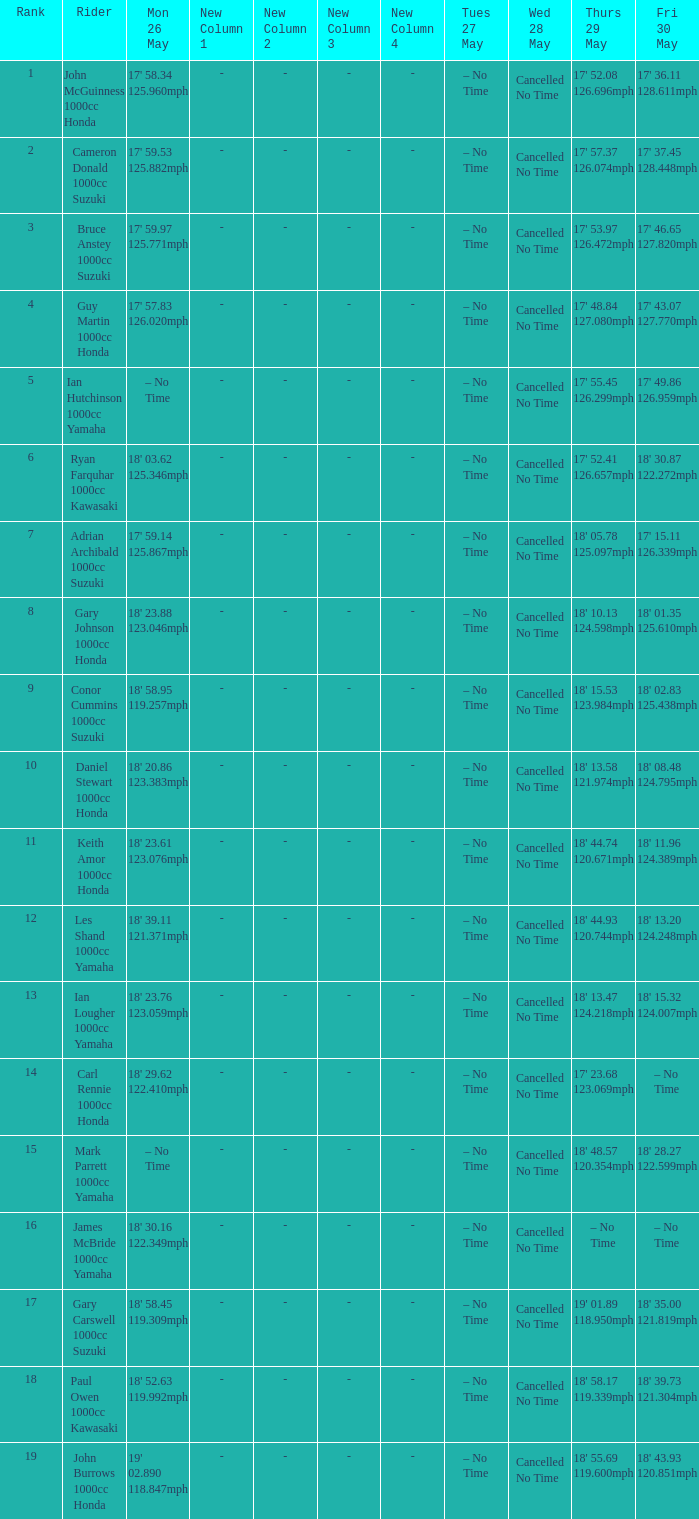What time is mon may 26 and fri may 30 is 18' 28.27 122.599mph? – No Time. 